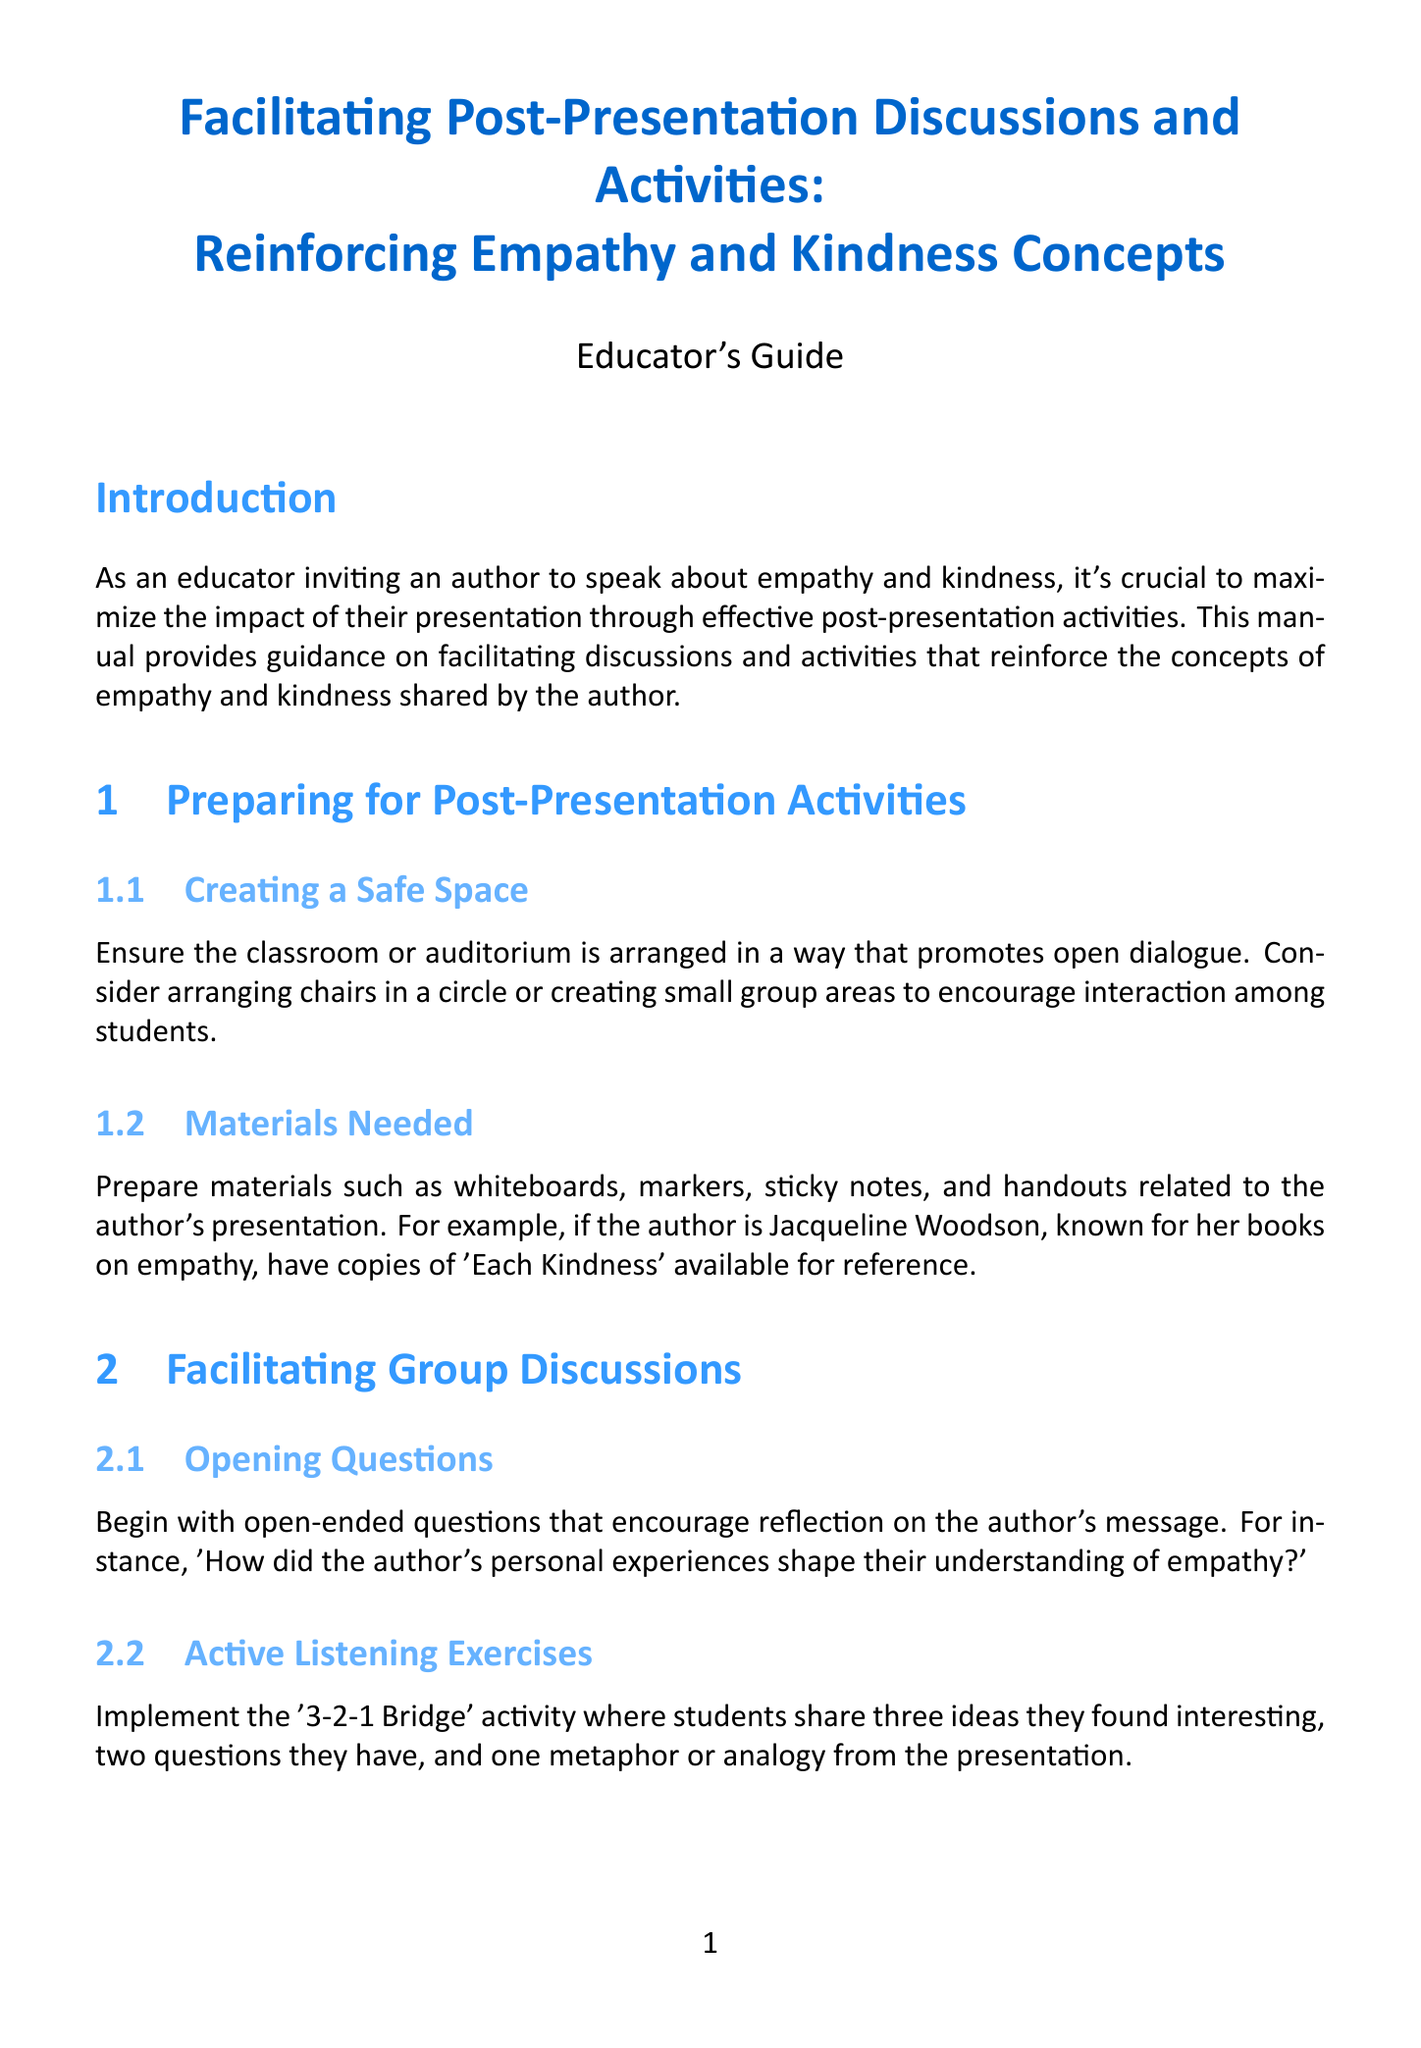What is the title of the manual? The title of the manual is given at the beginning, indicating its focus on discussions and activities related to empathy and kindness.
Answer: Facilitating Post-Presentation Discussions and Activities: Reinforcing Empathy and Kindness Concepts Who is an example author mentioned for book recommendations? The document includes examples of authors whose works promote empathy and kindness, such as Jacqueline Woodson.
Answer: Jacqueline Woodson What is the purpose of the '3-2-1 Bridge' activity? This activity is designed to promote active listening and encourage students to reflect on the presentation content.
Answer: Active listening What should students create for collaborative projects? The manual suggests organizing groups to design projects that enhance empathy and kindness within the school community.
Answer: Kindness campaign What type of writing exercise encourages personal reflection? This exercise prompts students to connect personally with their experiences of kindness as part of their learning process.
Answer: Personal connection journaling How many subsections are in the section for Interactive Activities? The section includes different subsections that provide specific guidance on activities related to empathy and kindness.
Answer: Two 